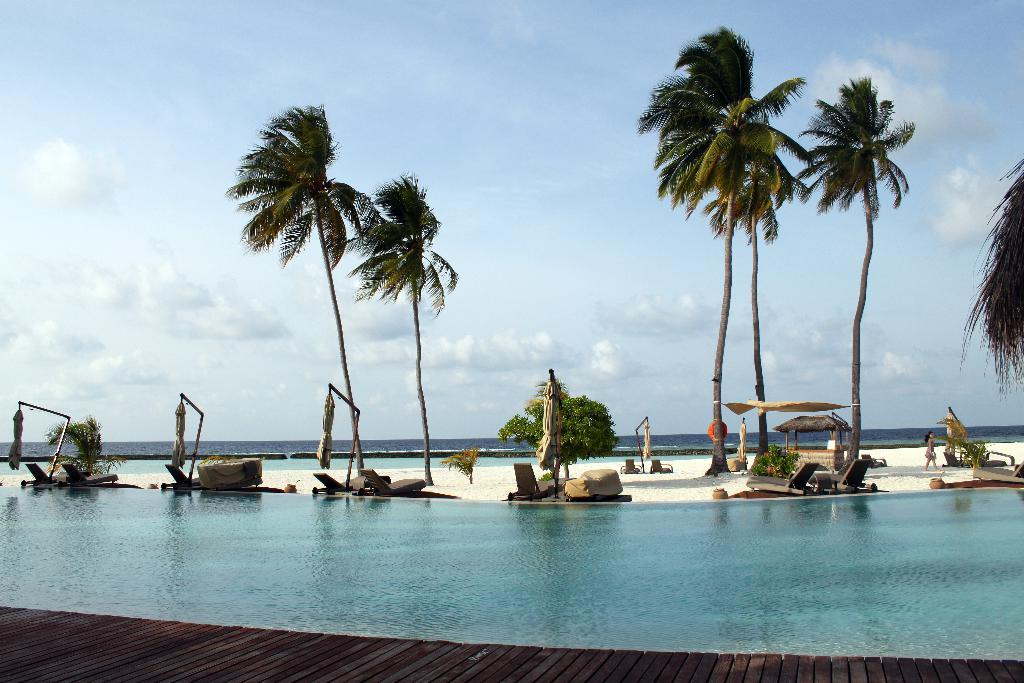What is the primary element visible in the image? There is water in the image. What type of furniture can be seen in the image? There are beach chairs in the image. What type of vegetation is present in the image? There are trees in the image. Can you describe the background of the image? There is water visible at the back of the image. What type of oil can be seen dripping from the trees in the image? There is no oil present in the image; it features water, beach chairs, and trees. 